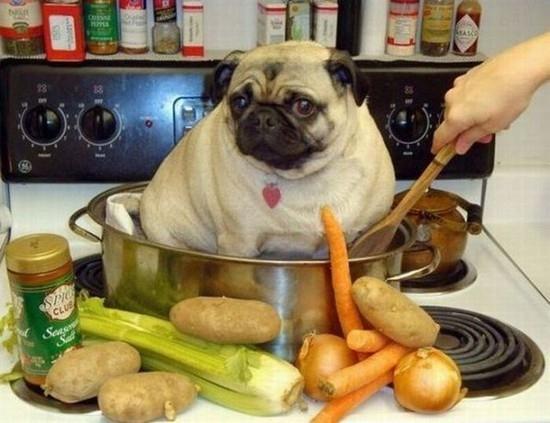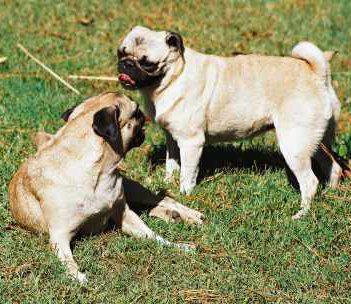The first image is the image on the left, the second image is the image on the right. Analyze the images presented: Is the assertion "Two buff beige pugs with dark muzzles, at least one wearing a collar, are close together and face to face in the right image." valid? Answer yes or no. No. The first image is the image on the left, the second image is the image on the right. Evaluate the accuracy of this statement regarding the images: "Two dogs are outside in the grass in the image on the right.". Is it true? Answer yes or no. Yes. 